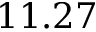<formula> <loc_0><loc_0><loc_500><loc_500>1 1 . 2 7</formula> 